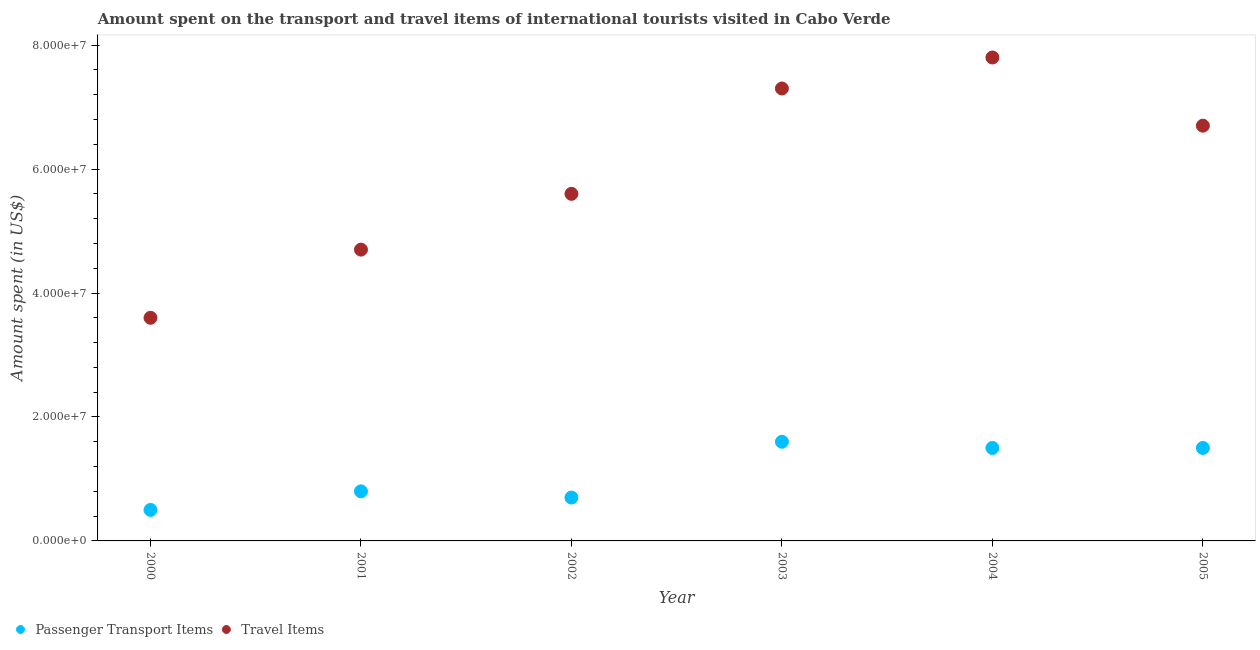What is the amount spent on passenger transport items in 2003?
Ensure brevity in your answer.  1.60e+07. Across all years, what is the maximum amount spent in travel items?
Give a very brief answer. 7.80e+07. Across all years, what is the minimum amount spent in travel items?
Give a very brief answer. 3.60e+07. In which year was the amount spent on passenger transport items minimum?
Ensure brevity in your answer.  2000. What is the total amount spent on passenger transport items in the graph?
Your answer should be compact. 6.60e+07. What is the difference between the amount spent in travel items in 2000 and that in 2005?
Your answer should be compact. -3.10e+07. What is the difference between the amount spent on passenger transport items in 2000 and the amount spent in travel items in 2004?
Your response must be concise. -7.30e+07. What is the average amount spent on passenger transport items per year?
Ensure brevity in your answer.  1.10e+07. In the year 2000, what is the difference between the amount spent on passenger transport items and amount spent in travel items?
Your response must be concise. -3.10e+07. In how many years, is the amount spent on passenger transport items greater than 4000000 US$?
Ensure brevity in your answer.  6. What is the ratio of the amount spent on passenger transport items in 2000 to that in 2002?
Give a very brief answer. 0.71. Is the difference between the amount spent in travel items in 2002 and 2003 greater than the difference between the amount spent on passenger transport items in 2002 and 2003?
Keep it short and to the point. No. What is the difference between the highest and the lowest amount spent in travel items?
Ensure brevity in your answer.  4.20e+07. Is the sum of the amount spent in travel items in 2001 and 2002 greater than the maximum amount spent on passenger transport items across all years?
Provide a short and direct response. Yes. Does the amount spent on passenger transport items monotonically increase over the years?
Keep it short and to the point. No. How many dotlines are there?
Provide a succinct answer. 2. How many years are there in the graph?
Ensure brevity in your answer.  6. What is the difference between two consecutive major ticks on the Y-axis?
Your answer should be very brief. 2.00e+07. Are the values on the major ticks of Y-axis written in scientific E-notation?
Make the answer very short. Yes. Does the graph contain any zero values?
Your answer should be compact. No. How are the legend labels stacked?
Your response must be concise. Horizontal. What is the title of the graph?
Your answer should be compact. Amount spent on the transport and travel items of international tourists visited in Cabo Verde. Does "Female labourers" appear as one of the legend labels in the graph?
Give a very brief answer. No. What is the label or title of the Y-axis?
Your answer should be very brief. Amount spent (in US$). What is the Amount spent (in US$) in Passenger Transport Items in 2000?
Provide a succinct answer. 5.00e+06. What is the Amount spent (in US$) in Travel Items in 2000?
Your response must be concise. 3.60e+07. What is the Amount spent (in US$) in Passenger Transport Items in 2001?
Provide a succinct answer. 8.00e+06. What is the Amount spent (in US$) of Travel Items in 2001?
Provide a short and direct response. 4.70e+07. What is the Amount spent (in US$) in Passenger Transport Items in 2002?
Offer a very short reply. 7.00e+06. What is the Amount spent (in US$) in Travel Items in 2002?
Give a very brief answer. 5.60e+07. What is the Amount spent (in US$) in Passenger Transport Items in 2003?
Provide a short and direct response. 1.60e+07. What is the Amount spent (in US$) in Travel Items in 2003?
Give a very brief answer. 7.30e+07. What is the Amount spent (in US$) in Passenger Transport Items in 2004?
Offer a very short reply. 1.50e+07. What is the Amount spent (in US$) in Travel Items in 2004?
Keep it short and to the point. 7.80e+07. What is the Amount spent (in US$) of Passenger Transport Items in 2005?
Give a very brief answer. 1.50e+07. What is the Amount spent (in US$) in Travel Items in 2005?
Offer a terse response. 6.70e+07. Across all years, what is the maximum Amount spent (in US$) of Passenger Transport Items?
Give a very brief answer. 1.60e+07. Across all years, what is the maximum Amount spent (in US$) of Travel Items?
Your answer should be compact. 7.80e+07. Across all years, what is the minimum Amount spent (in US$) of Passenger Transport Items?
Your answer should be very brief. 5.00e+06. Across all years, what is the minimum Amount spent (in US$) of Travel Items?
Give a very brief answer. 3.60e+07. What is the total Amount spent (in US$) in Passenger Transport Items in the graph?
Keep it short and to the point. 6.60e+07. What is the total Amount spent (in US$) of Travel Items in the graph?
Keep it short and to the point. 3.57e+08. What is the difference between the Amount spent (in US$) in Travel Items in 2000 and that in 2001?
Keep it short and to the point. -1.10e+07. What is the difference between the Amount spent (in US$) of Travel Items in 2000 and that in 2002?
Provide a short and direct response. -2.00e+07. What is the difference between the Amount spent (in US$) of Passenger Transport Items in 2000 and that in 2003?
Your response must be concise. -1.10e+07. What is the difference between the Amount spent (in US$) of Travel Items in 2000 and that in 2003?
Provide a succinct answer. -3.70e+07. What is the difference between the Amount spent (in US$) of Passenger Transport Items in 2000 and that in 2004?
Keep it short and to the point. -1.00e+07. What is the difference between the Amount spent (in US$) in Travel Items in 2000 and that in 2004?
Provide a short and direct response. -4.20e+07. What is the difference between the Amount spent (in US$) in Passenger Transport Items in 2000 and that in 2005?
Offer a terse response. -1.00e+07. What is the difference between the Amount spent (in US$) in Travel Items in 2000 and that in 2005?
Your answer should be very brief. -3.10e+07. What is the difference between the Amount spent (in US$) in Passenger Transport Items in 2001 and that in 2002?
Offer a very short reply. 1.00e+06. What is the difference between the Amount spent (in US$) of Travel Items in 2001 and that in 2002?
Make the answer very short. -9.00e+06. What is the difference between the Amount spent (in US$) of Passenger Transport Items in 2001 and that in 2003?
Make the answer very short. -8.00e+06. What is the difference between the Amount spent (in US$) in Travel Items in 2001 and that in 2003?
Your answer should be very brief. -2.60e+07. What is the difference between the Amount spent (in US$) of Passenger Transport Items in 2001 and that in 2004?
Your answer should be compact. -7.00e+06. What is the difference between the Amount spent (in US$) in Travel Items in 2001 and that in 2004?
Your answer should be compact. -3.10e+07. What is the difference between the Amount spent (in US$) in Passenger Transport Items in 2001 and that in 2005?
Your answer should be compact. -7.00e+06. What is the difference between the Amount spent (in US$) in Travel Items in 2001 and that in 2005?
Ensure brevity in your answer.  -2.00e+07. What is the difference between the Amount spent (in US$) in Passenger Transport Items in 2002 and that in 2003?
Your response must be concise. -9.00e+06. What is the difference between the Amount spent (in US$) of Travel Items in 2002 and that in 2003?
Ensure brevity in your answer.  -1.70e+07. What is the difference between the Amount spent (in US$) of Passenger Transport Items in 2002 and that in 2004?
Ensure brevity in your answer.  -8.00e+06. What is the difference between the Amount spent (in US$) in Travel Items in 2002 and that in 2004?
Provide a succinct answer. -2.20e+07. What is the difference between the Amount spent (in US$) in Passenger Transport Items in 2002 and that in 2005?
Make the answer very short. -8.00e+06. What is the difference between the Amount spent (in US$) of Travel Items in 2002 and that in 2005?
Offer a terse response. -1.10e+07. What is the difference between the Amount spent (in US$) of Travel Items in 2003 and that in 2004?
Keep it short and to the point. -5.00e+06. What is the difference between the Amount spent (in US$) of Passenger Transport Items in 2003 and that in 2005?
Offer a terse response. 1.00e+06. What is the difference between the Amount spent (in US$) of Travel Items in 2003 and that in 2005?
Provide a short and direct response. 6.00e+06. What is the difference between the Amount spent (in US$) of Passenger Transport Items in 2004 and that in 2005?
Offer a very short reply. 0. What is the difference between the Amount spent (in US$) of Travel Items in 2004 and that in 2005?
Your answer should be very brief. 1.10e+07. What is the difference between the Amount spent (in US$) in Passenger Transport Items in 2000 and the Amount spent (in US$) in Travel Items in 2001?
Provide a succinct answer. -4.20e+07. What is the difference between the Amount spent (in US$) of Passenger Transport Items in 2000 and the Amount spent (in US$) of Travel Items in 2002?
Your response must be concise. -5.10e+07. What is the difference between the Amount spent (in US$) in Passenger Transport Items in 2000 and the Amount spent (in US$) in Travel Items in 2003?
Offer a terse response. -6.80e+07. What is the difference between the Amount spent (in US$) of Passenger Transport Items in 2000 and the Amount spent (in US$) of Travel Items in 2004?
Provide a succinct answer. -7.30e+07. What is the difference between the Amount spent (in US$) of Passenger Transport Items in 2000 and the Amount spent (in US$) of Travel Items in 2005?
Provide a succinct answer. -6.20e+07. What is the difference between the Amount spent (in US$) of Passenger Transport Items in 2001 and the Amount spent (in US$) of Travel Items in 2002?
Keep it short and to the point. -4.80e+07. What is the difference between the Amount spent (in US$) of Passenger Transport Items in 2001 and the Amount spent (in US$) of Travel Items in 2003?
Keep it short and to the point. -6.50e+07. What is the difference between the Amount spent (in US$) of Passenger Transport Items in 2001 and the Amount spent (in US$) of Travel Items in 2004?
Make the answer very short. -7.00e+07. What is the difference between the Amount spent (in US$) of Passenger Transport Items in 2001 and the Amount spent (in US$) of Travel Items in 2005?
Your response must be concise. -5.90e+07. What is the difference between the Amount spent (in US$) in Passenger Transport Items in 2002 and the Amount spent (in US$) in Travel Items in 2003?
Provide a short and direct response. -6.60e+07. What is the difference between the Amount spent (in US$) of Passenger Transport Items in 2002 and the Amount spent (in US$) of Travel Items in 2004?
Provide a short and direct response. -7.10e+07. What is the difference between the Amount spent (in US$) in Passenger Transport Items in 2002 and the Amount spent (in US$) in Travel Items in 2005?
Your answer should be compact. -6.00e+07. What is the difference between the Amount spent (in US$) of Passenger Transport Items in 2003 and the Amount spent (in US$) of Travel Items in 2004?
Offer a very short reply. -6.20e+07. What is the difference between the Amount spent (in US$) in Passenger Transport Items in 2003 and the Amount spent (in US$) in Travel Items in 2005?
Provide a short and direct response. -5.10e+07. What is the difference between the Amount spent (in US$) of Passenger Transport Items in 2004 and the Amount spent (in US$) of Travel Items in 2005?
Your response must be concise. -5.20e+07. What is the average Amount spent (in US$) of Passenger Transport Items per year?
Ensure brevity in your answer.  1.10e+07. What is the average Amount spent (in US$) in Travel Items per year?
Provide a succinct answer. 5.95e+07. In the year 2000, what is the difference between the Amount spent (in US$) of Passenger Transport Items and Amount spent (in US$) of Travel Items?
Offer a terse response. -3.10e+07. In the year 2001, what is the difference between the Amount spent (in US$) in Passenger Transport Items and Amount spent (in US$) in Travel Items?
Provide a succinct answer. -3.90e+07. In the year 2002, what is the difference between the Amount spent (in US$) of Passenger Transport Items and Amount spent (in US$) of Travel Items?
Offer a terse response. -4.90e+07. In the year 2003, what is the difference between the Amount spent (in US$) in Passenger Transport Items and Amount spent (in US$) in Travel Items?
Ensure brevity in your answer.  -5.70e+07. In the year 2004, what is the difference between the Amount spent (in US$) of Passenger Transport Items and Amount spent (in US$) of Travel Items?
Your response must be concise. -6.30e+07. In the year 2005, what is the difference between the Amount spent (in US$) of Passenger Transport Items and Amount spent (in US$) of Travel Items?
Offer a terse response. -5.20e+07. What is the ratio of the Amount spent (in US$) in Travel Items in 2000 to that in 2001?
Your answer should be compact. 0.77. What is the ratio of the Amount spent (in US$) of Passenger Transport Items in 2000 to that in 2002?
Your answer should be compact. 0.71. What is the ratio of the Amount spent (in US$) of Travel Items in 2000 to that in 2002?
Offer a very short reply. 0.64. What is the ratio of the Amount spent (in US$) of Passenger Transport Items in 2000 to that in 2003?
Ensure brevity in your answer.  0.31. What is the ratio of the Amount spent (in US$) in Travel Items in 2000 to that in 2003?
Provide a short and direct response. 0.49. What is the ratio of the Amount spent (in US$) in Passenger Transport Items in 2000 to that in 2004?
Your answer should be compact. 0.33. What is the ratio of the Amount spent (in US$) of Travel Items in 2000 to that in 2004?
Keep it short and to the point. 0.46. What is the ratio of the Amount spent (in US$) of Passenger Transport Items in 2000 to that in 2005?
Your answer should be very brief. 0.33. What is the ratio of the Amount spent (in US$) in Travel Items in 2000 to that in 2005?
Offer a very short reply. 0.54. What is the ratio of the Amount spent (in US$) of Travel Items in 2001 to that in 2002?
Provide a short and direct response. 0.84. What is the ratio of the Amount spent (in US$) of Travel Items in 2001 to that in 2003?
Ensure brevity in your answer.  0.64. What is the ratio of the Amount spent (in US$) of Passenger Transport Items in 2001 to that in 2004?
Make the answer very short. 0.53. What is the ratio of the Amount spent (in US$) in Travel Items in 2001 to that in 2004?
Keep it short and to the point. 0.6. What is the ratio of the Amount spent (in US$) in Passenger Transport Items in 2001 to that in 2005?
Keep it short and to the point. 0.53. What is the ratio of the Amount spent (in US$) of Travel Items in 2001 to that in 2005?
Ensure brevity in your answer.  0.7. What is the ratio of the Amount spent (in US$) in Passenger Transport Items in 2002 to that in 2003?
Your answer should be very brief. 0.44. What is the ratio of the Amount spent (in US$) of Travel Items in 2002 to that in 2003?
Your answer should be compact. 0.77. What is the ratio of the Amount spent (in US$) of Passenger Transport Items in 2002 to that in 2004?
Your answer should be very brief. 0.47. What is the ratio of the Amount spent (in US$) of Travel Items in 2002 to that in 2004?
Keep it short and to the point. 0.72. What is the ratio of the Amount spent (in US$) in Passenger Transport Items in 2002 to that in 2005?
Offer a very short reply. 0.47. What is the ratio of the Amount spent (in US$) in Travel Items in 2002 to that in 2005?
Ensure brevity in your answer.  0.84. What is the ratio of the Amount spent (in US$) of Passenger Transport Items in 2003 to that in 2004?
Give a very brief answer. 1.07. What is the ratio of the Amount spent (in US$) in Travel Items in 2003 to that in 2004?
Offer a terse response. 0.94. What is the ratio of the Amount spent (in US$) in Passenger Transport Items in 2003 to that in 2005?
Your response must be concise. 1.07. What is the ratio of the Amount spent (in US$) of Travel Items in 2003 to that in 2005?
Keep it short and to the point. 1.09. What is the ratio of the Amount spent (in US$) of Passenger Transport Items in 2004 to that in 2005?
Your answer should be compact. 1. What is the ratio of the Amount spent (in US$) of Travel Items in 2004 to that in 2005?
Your answer should be compact. 1.16. What is the difference between the highest and the second highest Amount spent (in US$) of Travel Items?
Your response must be concise. 5.00e+06. What is the difference between the highest and the lowest Amount spent (in US$) in Passenger Transport Items?
Make the answer very short. 1.10e+07. What is the difference between the highest and the lowest Amount spent (in US$) in Travel Items?
Offer a terse response. 4.20e+07. 